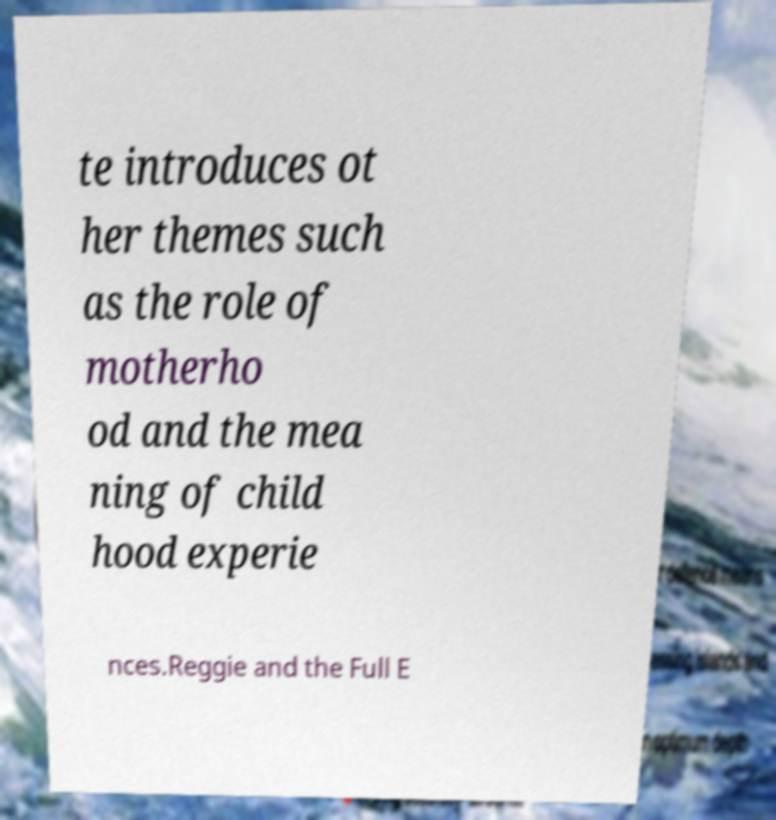Please read and relay the text visible in this image. What does it say? te introduces ot her themes such as the role of motherho od and the mea ning of child hood experie nces.Reggie and the Full E 